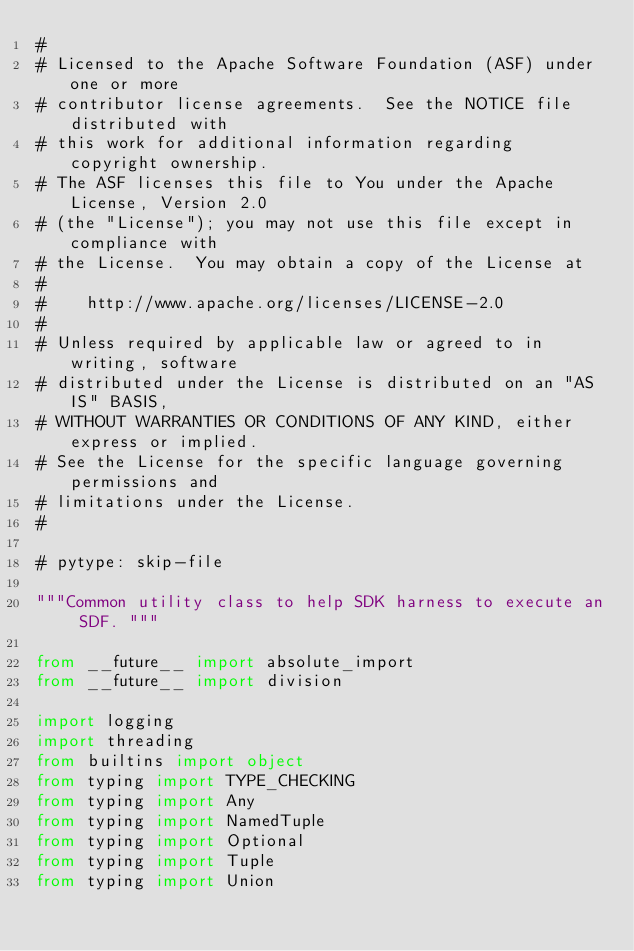Convert code to text. <code><loc_0><loc_0><loc_500><loc_500><_Python_>#
# Licensed to the Apache Software Foundation (ASF) under one or more
# contributor license agreements.  See the NOTICE file distributed with
# this work for additional information regarding copyright ownership.
# The ASF licenses this file to You under the Apache License, Version 2.0
# (the "License"); you may not use this file except in compliance with
# the License.  You may obtain a copy of the License at
#
#    http://www.apache.org/licenses/LICENSE-2.0
#
# Unless required by applicable law or agreed to in writing, software
# distributed under the License is distributed on an "AS IS" BASIS,
# WITHOUT WARRANTIES OR CONDITIONS OF ANY KIND, either express or implied.
# See the License for the specific language governing permissions and
# limitations under the License.
#

# pytype: skip-file

"""Common utility class to help SDK harness to execute an SDF. """

from __future__ import absolute_import
from __future__ import division

import logging
import threading
from builtins import object
from typing import TYPE_CHECKING
from typing import Any
from typing import NamedTuple
from typing import Optional
from typing import Tuple
from typing import Union
</code> 